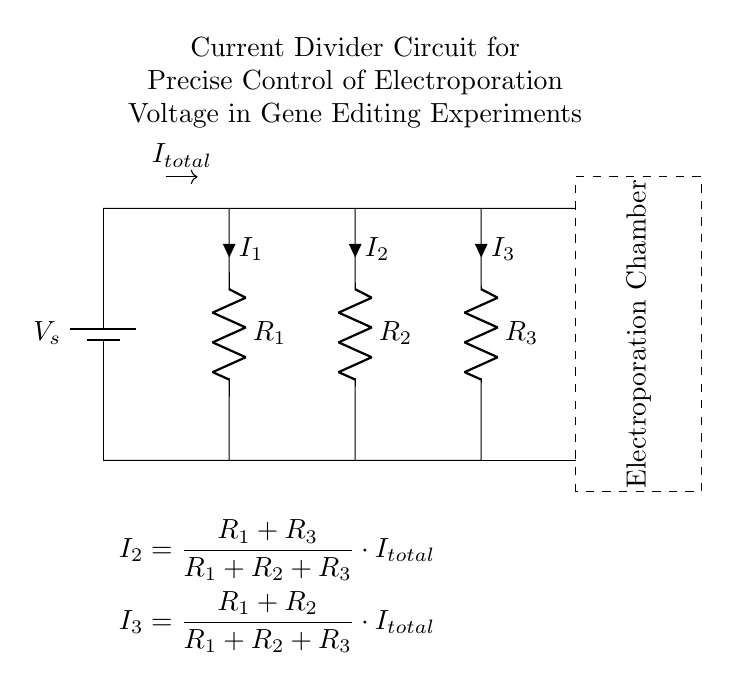What is the total current flowing in the circuit? The circuit indicates a total current labeled as I total, but the specific value is not given in the diagram. We assume it's the current supplied by the source.
Answer: I total What components are present in the circuit? The circuit contains a voltage source, three resistors, and an electroporation chamber. These elements are essential for controlling the current and voltage.
Answer: Voltage source, resistors, electroporation chamber How many resistors are in parallel? There are two resistors, R2 and R3, that are connected in parallel within this circuit configuration.
Answer: Two What does the dashed rectangle represent? The dashed rectangle outlines the boundaries of the electroporation chamber, showing where the controlled electroporation takes place using the current from the resistors.
Answer: Electroporation Chamber What is the relationship between I2 and I3? According to the equations derived from the current divider principle, the values of I2 and I3 are proportional to the resistances; thus higher resistance in a path will result in lower current through that path and vice versa.
Answer: Proportional What is the purpose of this current divider circuit? The circuit's main purpose is to allow precise control of the voltage that is applied to the electroporation chamber during gene editing experiments, which is critical for ensuring effective delivery of genetic material.
Answer: Control of electroporation voltage 